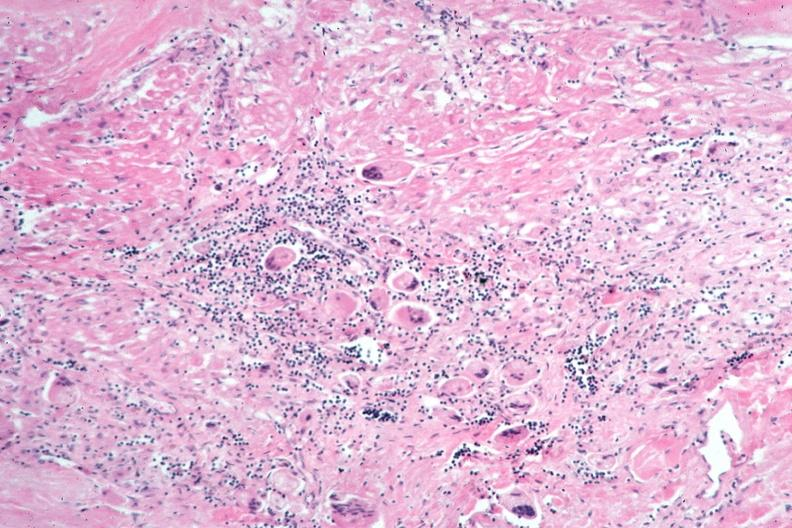does this image show lung, sarcoidosis, multinucleated giant cells?
Answer the question using a single word or phrase. Yes 